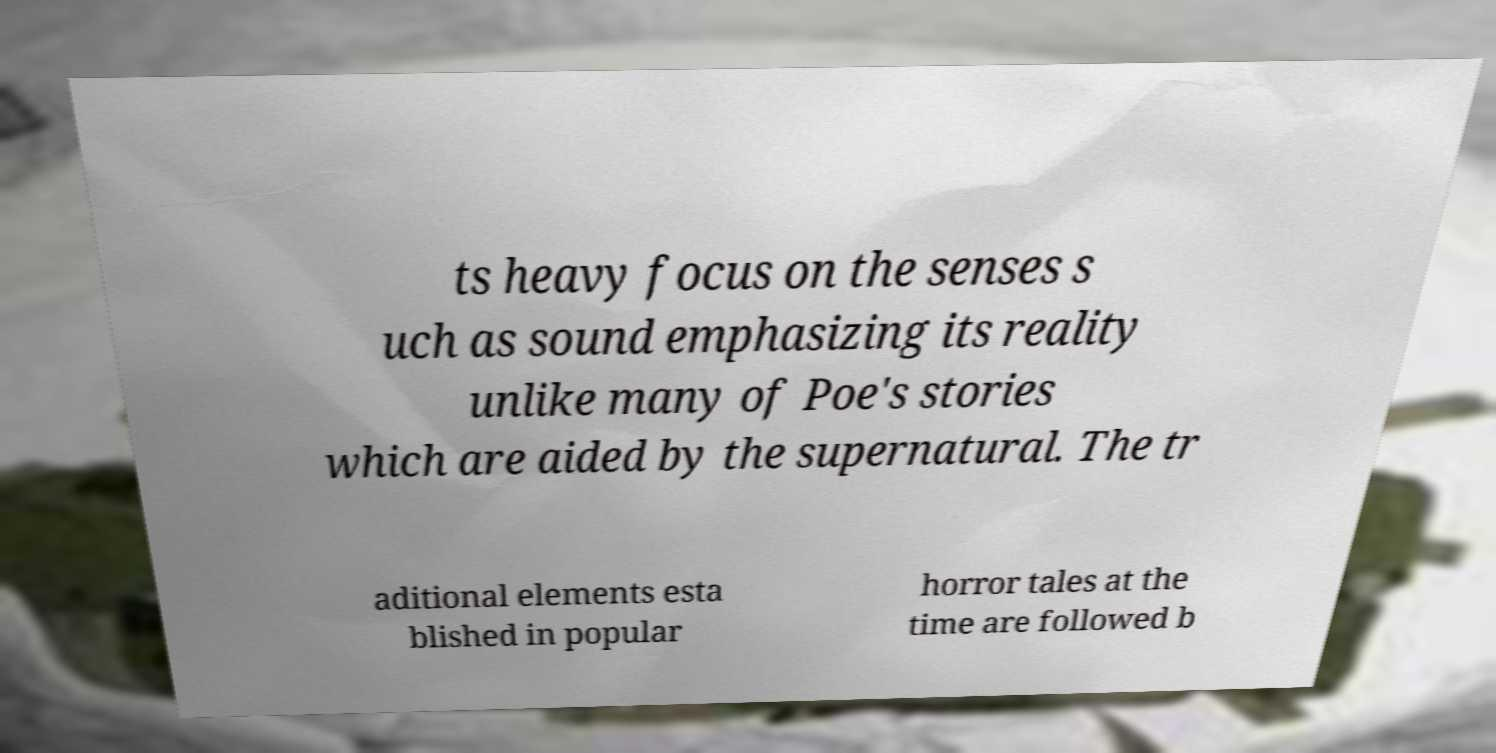What messages or text are displayed in this image? I need them in a readable, typed format. ts heavy focus on the senses s uch as sound emphasizing its reality unlike many of Poe's stories which are aided by the supernatural. The tr aditional elements esta blished in popular horror tales at the time are followed b 